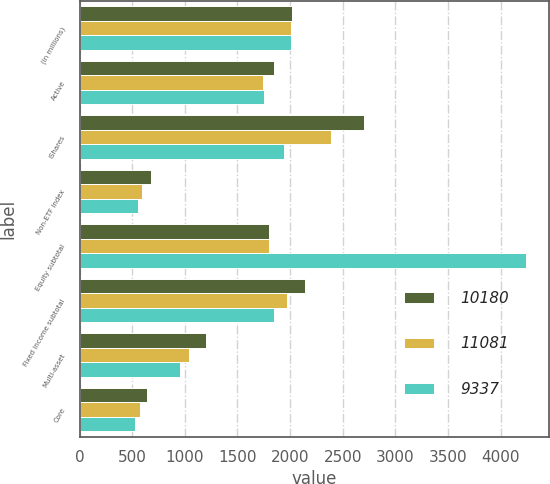Convert chart. <chart><loc_0><loc_0><loc_500><loc_500><stacked_bar_chart><ecel><fcel>(in millions)<fcel>Active<fcel>iShares<fcel>Non-ETF index<fcel>Equity subtotal<fcel>Fixed income subtotal<fcel>Multi-asset<fcel>Core<nl><fcel>10180<fcel>2014<fcel>1844<fcel>2705<fcel>677<fcel>1798.5<fcel>2140<fcel>1204<fcel>638<nl><fcel>11081<fcel>2013<fcel>1741<fcel>2390<fcel>594<fcel>1798.5<fcel>1971<fcel>1039<fcel>576<nl><fcel>9337<fcel>2012<fcel>1753<fcel>1941<fcel>552<fcel>4246<fcel>1852<fcel>957<fcel>525<nl></chart> 